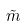Convert formula to latex. <formula><loc_0><loc_0><loc_500><loc_500>\tilde { m }</formula> 